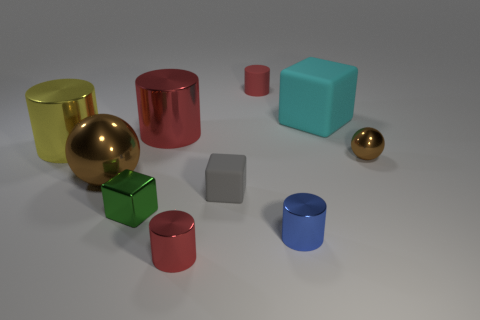How many red cylinders must be subtracted to get 1 red cylinders? 2 Subtract all big red cylinders. How many cylinders are left? 4 Subtract all red cylinders. How many cylinders are left? 2 Subtract all blocks. How many objects are left? 7 Add 9 big yellow shiny cylinders. How many big yellow shiny cylinders are left? 10 Add 6 tiny gray rubber cubes. How many tiny gray rubber cubes exist? 7 Subtract 1 cyan blocks. How many objects are left? 9 Subtract 2 cylinders. How many cylinders are left? 3 Subtract all gray cubes. Subtract all green cylinders. How many cubes are left? 2 Subtract all gray cubes. How many red cylinders are left? 3 